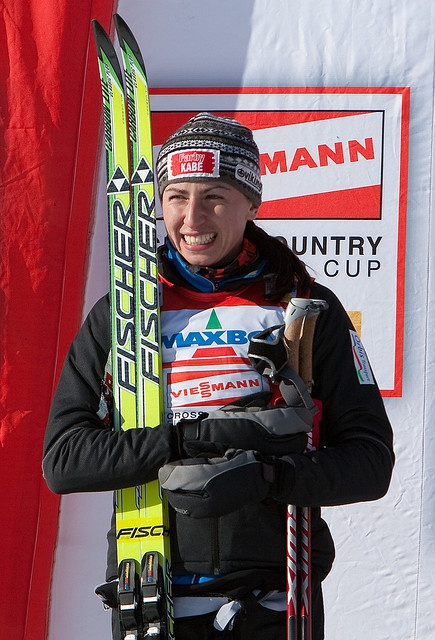Describe the objects in this image and their specific colors. I can see people in brown, black, gray, lightgray, and maroon tones and skis in brown, black, khaki, white, and gray tones in this image. 